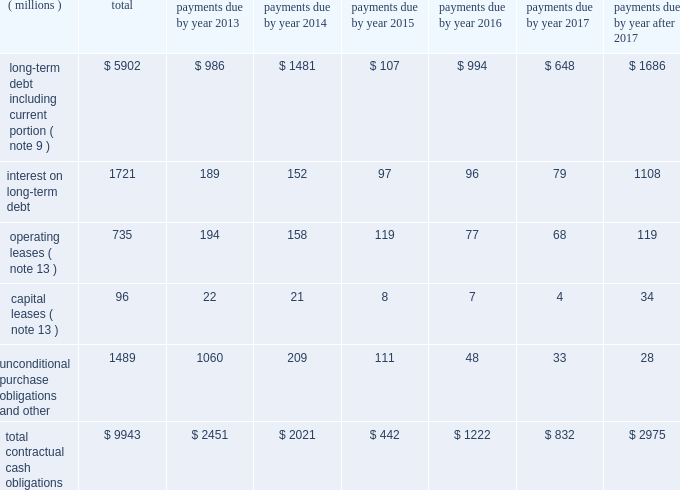Japanese yen ( approximately $ 63 million and $ 188 million , respectively , based on applicable exchange rates at that time ) .
The cash paid of approximately $ 63 million during the quarter ended march 31 , 2010 as a result of the purchase of sumitomo 3m shares from sei is classified as 201cother financing activities 201d in the consolidated statement of cash flows .
The remainder of the purchase financed by the note payable to sei is considered non-cash financing activity in the first quarter of 2010 .
As discussed in note 2 , during the second quarter of 2010 , 3m recorded a financed liability of 1.7 billion japanese yen ( approximately $ 18 million based on applicable exchange rates at that time ) related to the a-one acquisition , which is also considered a non-cash financing activity .
Off-balance sheet arrangements and contractual obligations : as of december 31 , 2012 , the company has not utilized special purpose entities to facilitate off-balance sheet financing arrangements .
Refer to the section entitled 201cwarranties/guarantees 201d in note 13 for discussion of accrued product warranty liabilities and guarantees .
In addition to guarantees , 3m , in the normal course of business , periodically enters into agreements that require the company to indemnify either major customers or suppliers for specific risks , such as claims for injury or property damage arising out of the use of 3m products or the negligence of 3m personnel , or claims alleging that 3m products infringe third- party patents or other intellectual property .
While 3m 2019s maximum exposure under these indemnification provisions cannot be estimated , these indemnifications are not expected to have a material impact on the company 2019s consolidated results of operations or financial condition .
A summary of the company 2019s significant contractual obligations as of december 31 , 2012 , follows : contractual obligations .
Long-term debt payments due in 2013 and 2014 include floating rate notes totaling $ 132 million ( classified as current portion of long-term debt ) and $ 97 million , respectively , as a result of put provisions associated with these debt instruments .
Unconditional purchase obligations are defined as an agreement to purchase goods or services that is enforceable and legally binding on the company .
Included in the unconditional purchase obligations category above are certain obligations related to take or pay contracts , capital commitments , service agreements and utilities .
These estimates include both unconditional purchase obligations with terms in excess of one year and normal ongoing purchase obligations with terms of less than one year .
Many of these commitments relate to take or pay contracts , in which 3m guarantees payment to ensure availability of products or services that are sold to customers .
The company expects to receive consideration ( products or services ) for these unconditional purchase obligations .
Contractual capital commitments are included in the preceding table , but these commitments represent a small part of the company 2019s expected capital spending in 2013 and beyond .
The purchase obligation amounts do not represent the entire anticipated purchases in the future , but represent only those items for which the company is contractually obligated .
The majority of 3m 2019s products and services are purchased as needed , with no unconditional commitment .
For this reason , these amounts will not provide a reliable indicator of the company 2019s expected future cash outflows on a stand-alone basis .
Other obligations , included in the preceding table within the caption entitled 201cunconditional purchase obligations and other , 201d include the current portion of the liability for uncertain tax positions under asc 740 , which is expected to be paid out in cash in the next 12 months .
The company is not able to reasonably estimate the timing of the long-term payments or the amount by which the liability will increase or decrease over time ; therefore , the long-term portion of the net tax liability of $ 170 million is excluded from the preceding table .
Refer to note 7 for further details. .
Based on the summary of the company 2019s significant contractual obligations as of december 31 , 2012 what is the percent of the long-term debt including current portion to the total contractual cash obligations? 
Rationale: as of december 31 , 2012 59.4% of the the total contractual cash obligations was long-term debt including current portion
Computations: (5902 / 9943)
Answer: 0.59358. 